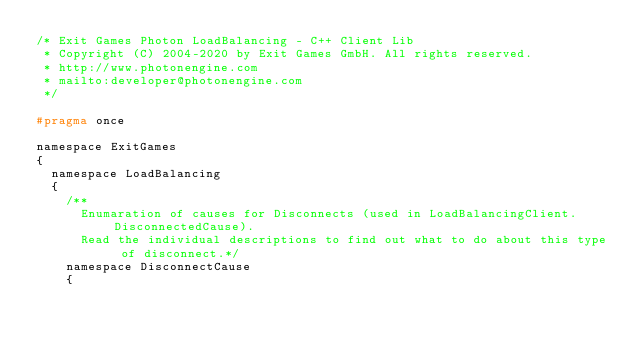<code> <loc_0><loc_0><loc_500><loc_500><_C_>/* Exit Games Photon LoadBalancing - C++ Client Lib
 * Copyright (C) 2004-2020 by Exit Games GmbH. All rights reserved.
 * http://www.photonengine.com
 * mailto:developer@photonengine.com
 */

#pragma once

namespace ExitGames
{
	namespace LoadBalancing
	{
		/** 
			Enumaration of causes for Disconnects (used in LoadBalancingClient.DisconnectedCause).
			Read the individual descriptions to find out what to do about this type of disconnect.*/
		namespace DisconnectCause
		{</code> 